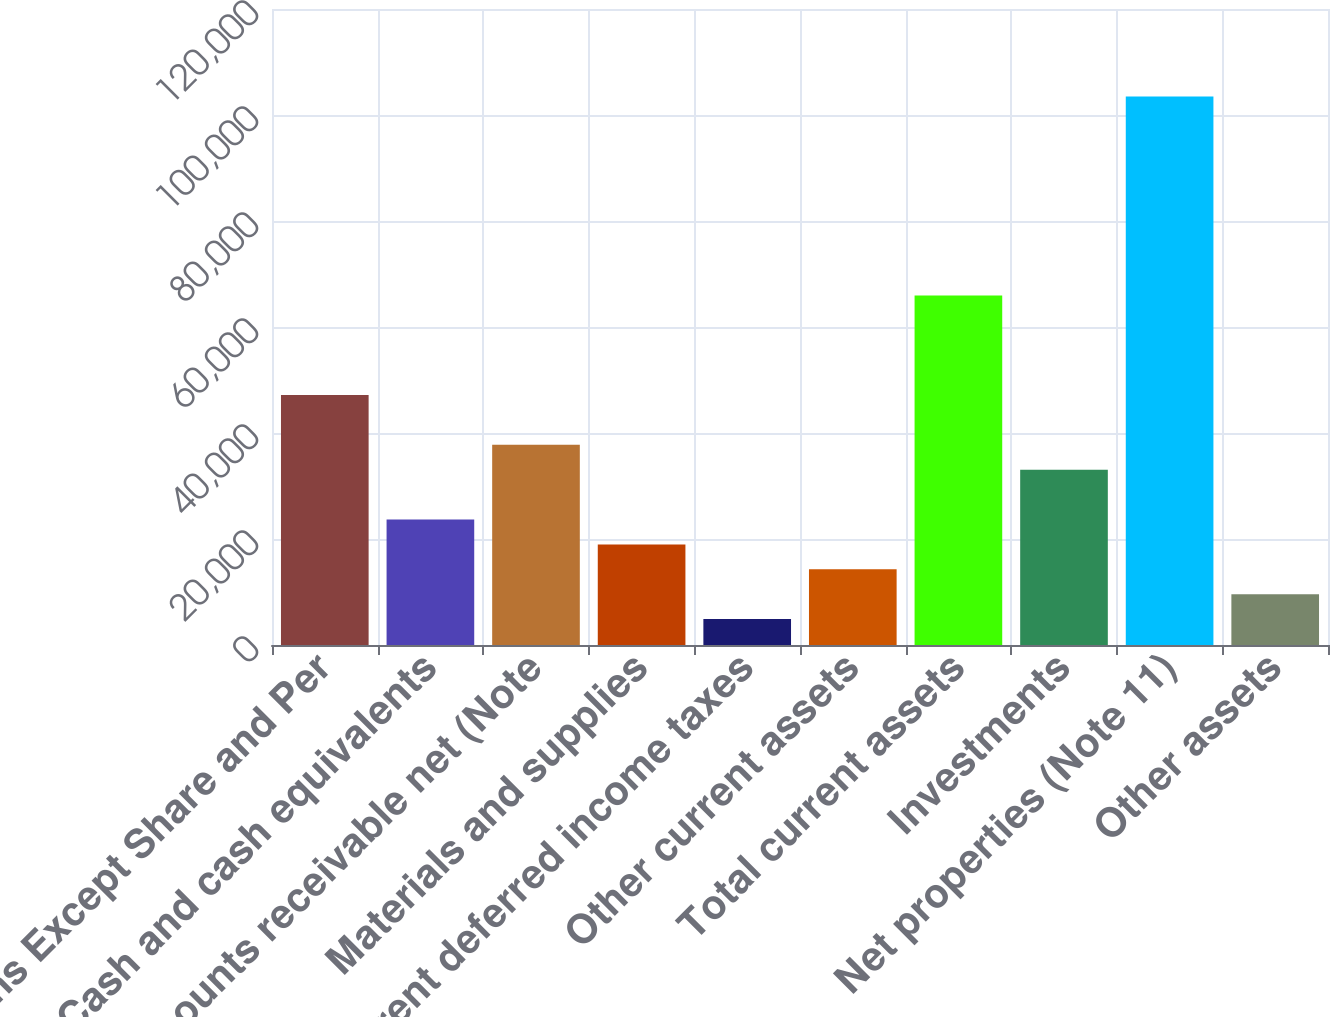Convert chart to OTSL. <chart><loc_0><loc_0><loc_500><loc_500><bar_chart><fcel>Millions Except Share and Per<fcel>Cash and cash equivalents<fcel>Accounts receivable net (Note<fcel>Materials and supplies<fcel>Current deferred income taxes<fcel>Other current assets<fcel>Total current assets<fcel>Investments<fcel>Net properties (Note 11)<fcel>Other assets<nl><fcel>47153<fcel>23674.5<fcel>37761.6<fcel>18978.8<fcel>4891.7<fcel>14283.1<fcel>65935.8<fcel>33065.9<fcel>103501<fcel>9587.4<nl></chart> 